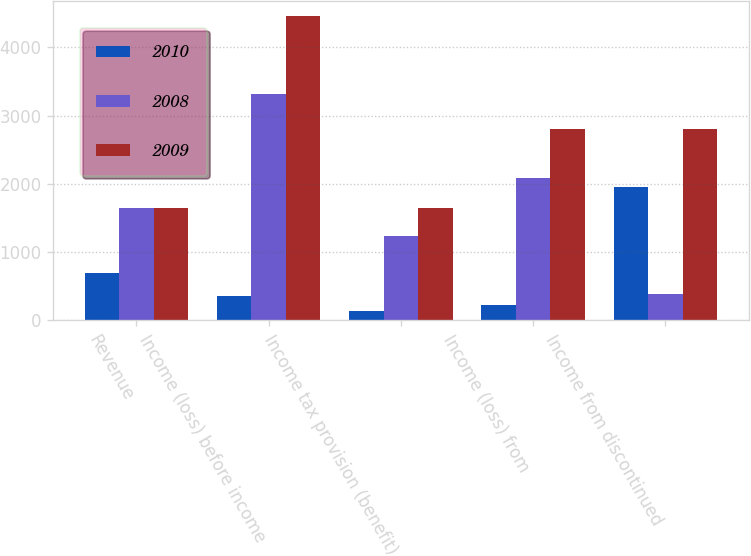<chart> <loc_0><loc_0><loc_500><loc_500><stacked_bar_chart><ecel><fcel>Revenue<fcel>Income (loss) before income<fcel>Income tax provision (benefit)<fcel>Income (loss) from<fcel>Income from discontinued<nl><fcel>2010<fcel>686<fcel>355<fcel>131<fcel>224<fcel>1953<nl><fcel>2008<fcel>1648<fcel>3314<fcel>1226<fcel>2088<fcel>384<nl><fcel>2009<fcel>1648<fcel>4455<fcel>1648<fcel>2807<fcel>2807<nl></chart> 